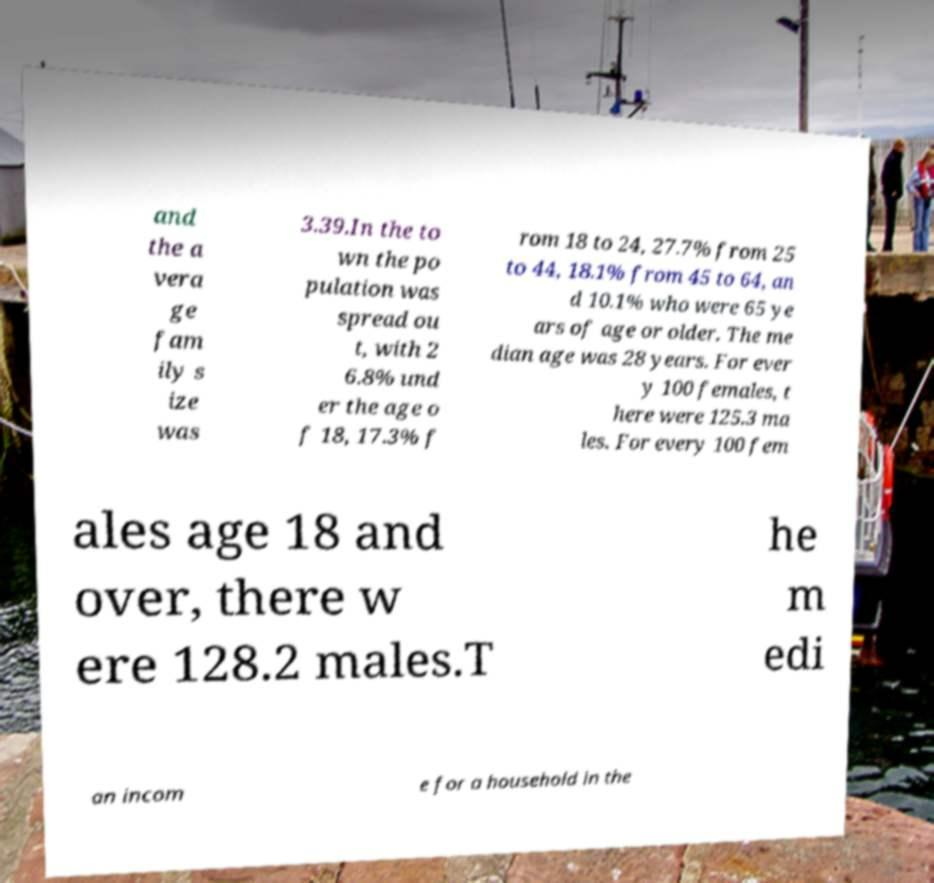Could you assist in decoding the text presented in this image and type it out clearly? and the a vera ge fam ily s ize was 3.39.In the to wn the po pulation was spread ou t, with 2 6.8% und er the age o f 18, 17.3% f rom 18 to 24, 27.7% from 25 to 44, 18.1% from 45 to 64, an d 10.1% who were 65 ye ars of age or older. The me dian age was 28 years. For ever y 100 females, t here were 125.3 ma les. For every 100 fem ales age 18 and over, there w ere 128.2 males.T he m edi an incom e for a household in the 